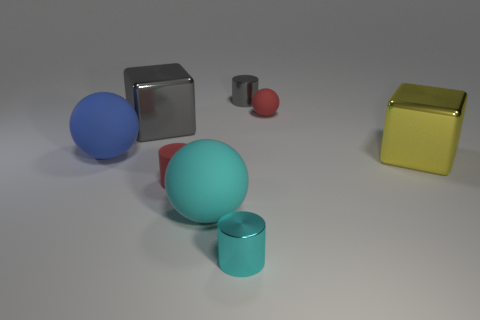Subtract 1 cylinders. How many cylinders are left? 2 Subtract all metallic cylinders. How many cylinders are left? 1 Add 1 large cyan rubber cubes. How many objects exist? 9 Subtract all balls. How many objects are left? 5 Add 3 large blue matte cylinders. How many large blue matte cylinders exist? 3 Subtract 0 gray spheres. How many objects are left? 8 Subtract all cyan rubber objects. Subtract all big blue matte objects. How many objects are left? 6 Add 6 big cubes. How many big cubes are left? 8 